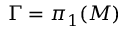Convert formula to latex. <formula><loc_0><loc_0><loc_500><loc_500>\Gamma = \pi _ { 1 } ( M )</formula> 